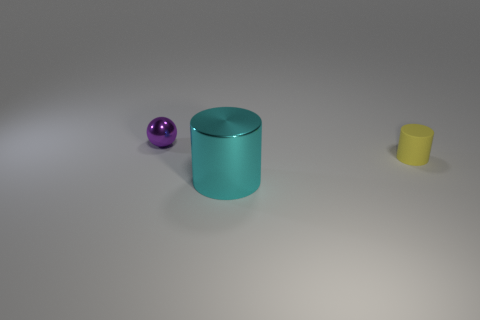Subtract 1 spheres. How many spheres are left? 0 Add 3 small yellow cylinders. How many objects exist? 6 Subtract all cylinders. How many objects are left? 1 Add 2 large matte balls. How many large matte balls exist? 2 Subtract 0 green balls. How many objects are left? 3 Subtract all red cylinders. Subtract all brown cubes. How many cylinders are left? 2 Subtract all blue blocks. How many cyan cylinders are left? 1 Subtract all balls. Subtract all tiny green matte things. How many objects are left? 2 Add 1 matte objects. How many matte objects are left? 2 